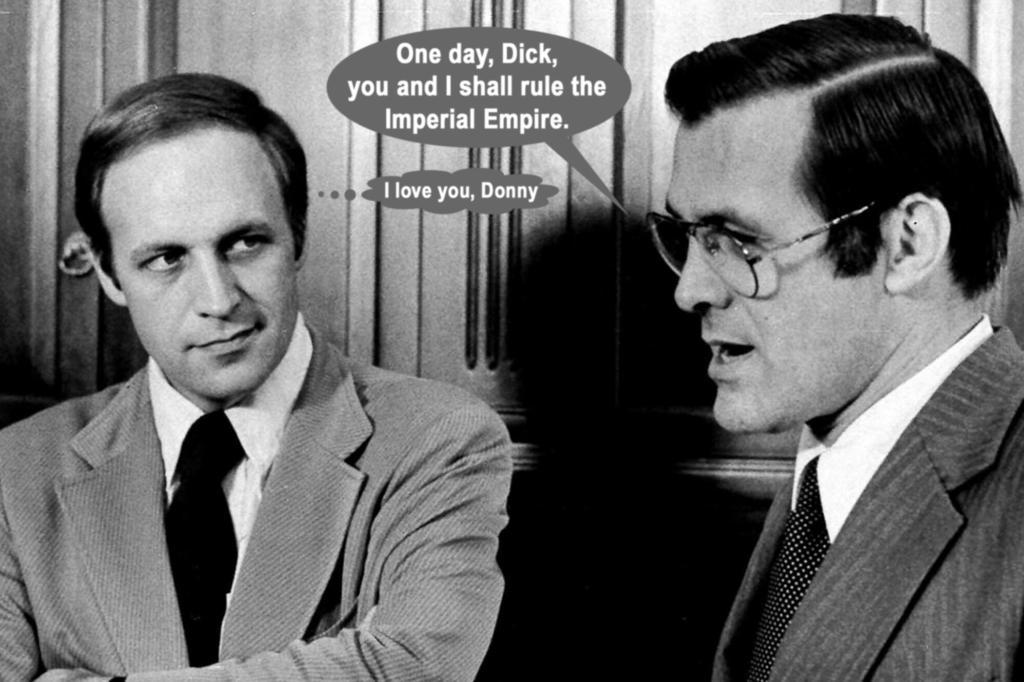Please provide a concise description of this image. In this image I can see a poster. 2 people are present, wearing suit. There is some text written in the center. There is a wooden background and this is a black and white image. 